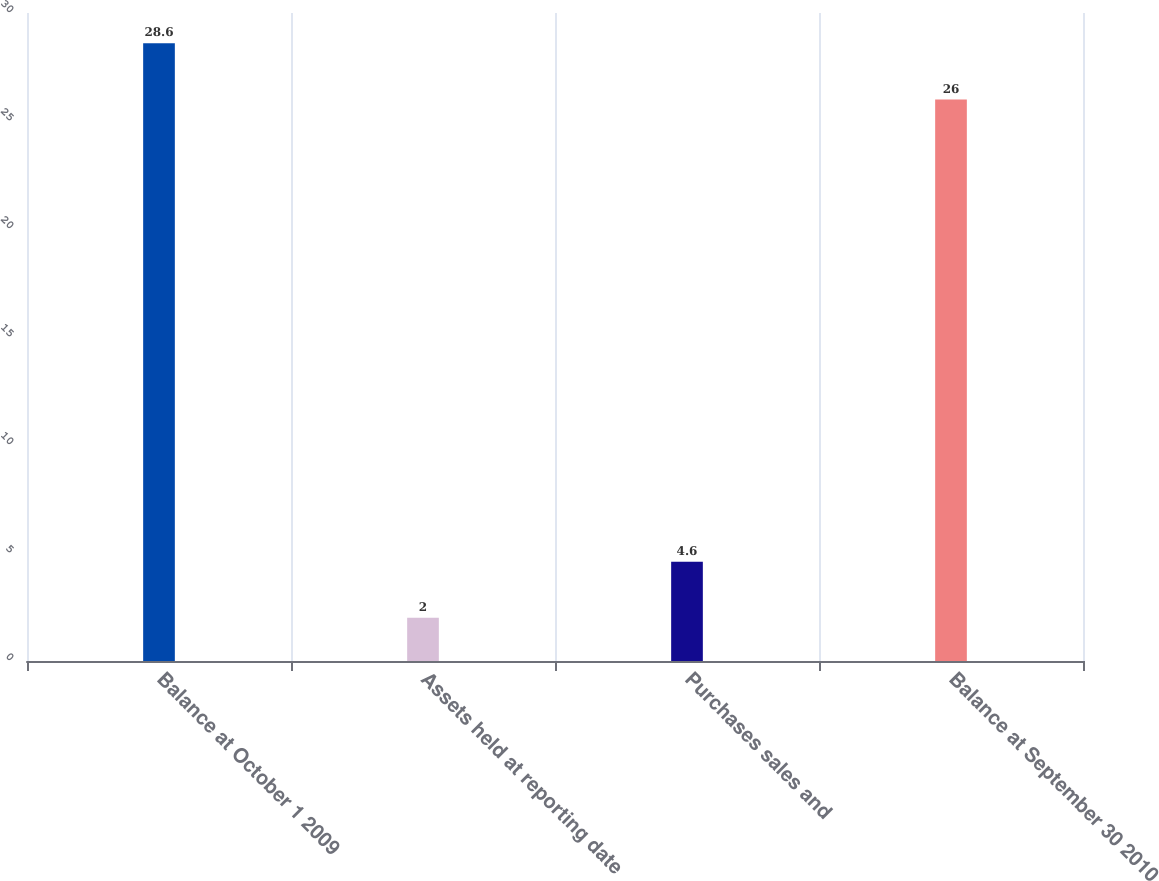Convert chart to OTSL. <chart><loc_0><loc_0><loc_500><loc_500><bar_chart><fcel>Balance at October 1 2009<fcel>Assets held at reporting date<fcel>Purchases sales and<fcel>Balance at September 30 2010<nl><fcel>28.6<fcel>2<fcel>4.6<fcel>26<nl></chart> 